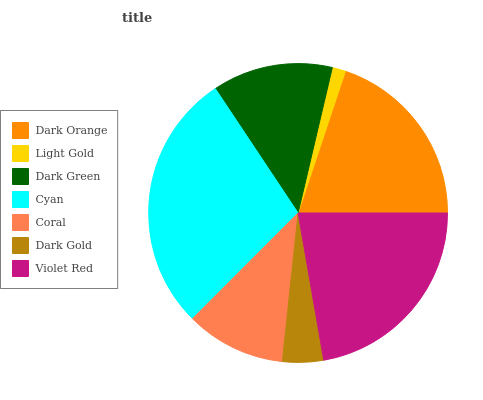Is Light Gold the minimum?
Answer yes or no. Yes. Is Cyan the maximum?
Answer yes or no. Yes. Is Dark Green the minimum?
Answer yes or no. No. Is Dark Green the maximum?
Answer yes or no. No. Is Dark Green greater than Light Gold?
Answer yes or no. Yes. Is Light Gold less than Dark Green?
Answer yes or no. Yes. Is Light Gold greater than Dark Green?
Answer yes or no. No. Is Dark Green less than Light Gold?
Answer yes or no. No. Is Dark Green the high median?
Answer yes or no. Yes. Is Dark Green the low median?
Answer yes or no. Yes. Is Dark Orange the high median?
Answer yes or no. No. Is Dark Gold the low median?
Answer yes or no. No. 